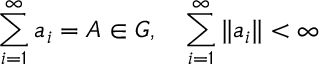Convert formula to latex. <formula><loc_0><loc_0><loc_500><loc_500>\sum _ { i = 1 } ^ { \infty } a _ { i } = A \in G , \quad \sum _ { i = 1 } ^ { \infty } \| a _ { i } \| < \infty</formula> 